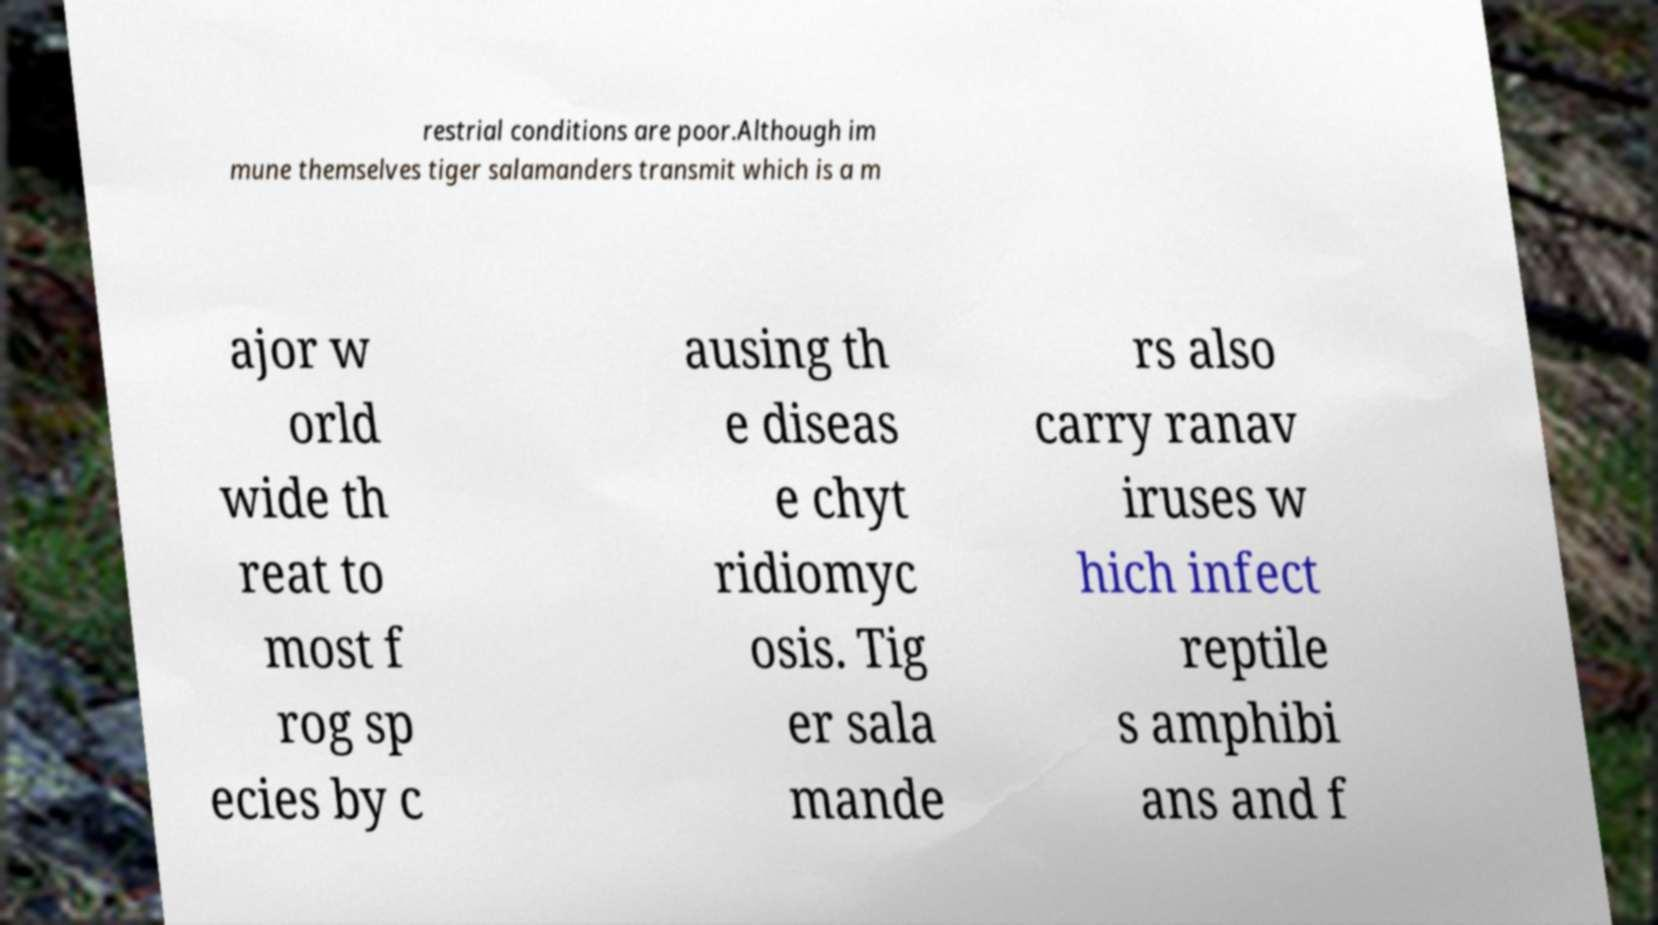There's text embedded in this image that I need extracted. Can you transcribe it verbatim? restrial conditions are poor.Although im mune themselves tiger salamanders transmit which is a m ajor w orld wide th reat to most f rog sp ecies by c ausing th e diseas e chyt ridiomyc osis. Tig er sala mande rs also carry ranav iruses w hich infect reptile s amphibi ans and f 